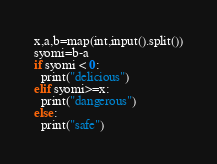Convert code to text. <code><loc_0><loc_0><loc_500><loc_500><_Python_>x,a,b=map(int,input().split())
syomi=b-a
if syomi < 0:
  print("delicious")
elif syomi>=x:
  print("dangerous")
else:
  print("safe")</code> 